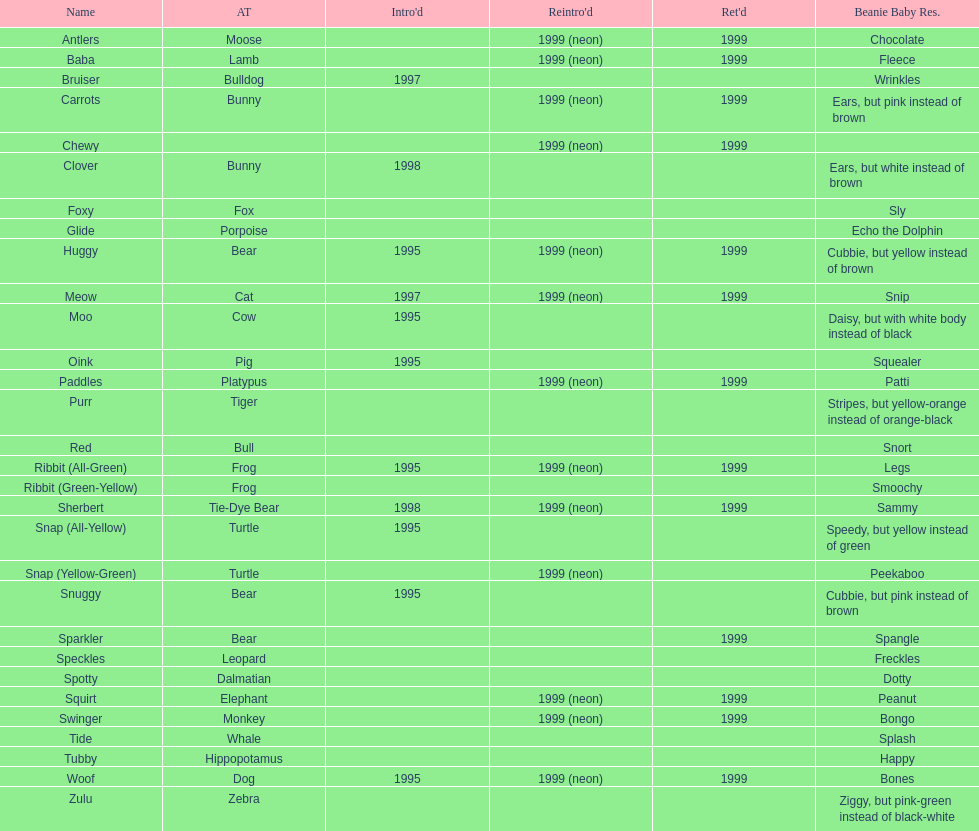What is the name of the pillow pal listed after clover? Foxy. 